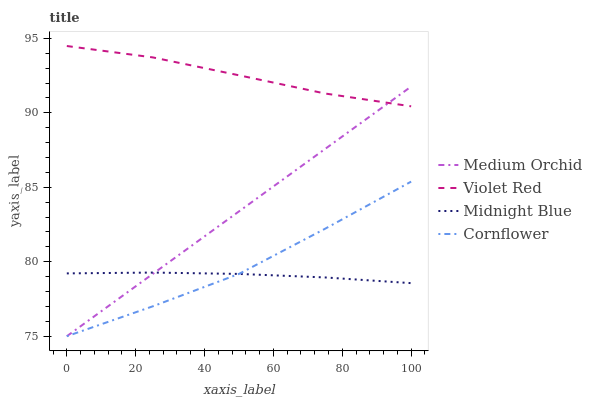Does Midnight Blue have the minimum area under the curve?
Answer yes or no. Yes. Does Violet Red have the maximum area under the curve?
Answer yes or no. Yes. Does Medium Orchid have the minimum area under the curve?
Answer yes or no. No. Does Medium Orchid have the maximum area under the curve?
Answer yes or no. No. Is Medium Orchid the smoothest?
Answer yes or no. Yes. Is Cornflower the roughest?
Answer yes or no. Yes. Is Violet Red the smoothest?
Answer yes or no. No. Is Violet Red the roughest?
Answer yes or no. No. Does Cornflower have the lowest value?
Answer yes or no. Yes. Does Violet Red have the lowest value?
Answer yes or no. No. Does Violet Red have the highest value?
Answer yes or no. Yes. Does Medium Orchid have the highest value?
Answer yes or no. No. Is Midnight Blue less than Violet Red?
Answer yes or no. Yes. Is Violet Red greater than Cornflower?
Answer yes or no. Yes. Does Midnight Blue intersect Cornflower?
Answer yes or no. Yes. Is Midnight Blue less than Cornflower?
Answer yes or no. No. Is Midnight Blue greater than Cornflower?
Answer yes or no. No. Does Midnight Blue intersect Violet Red?
Answer yes or no. No. 